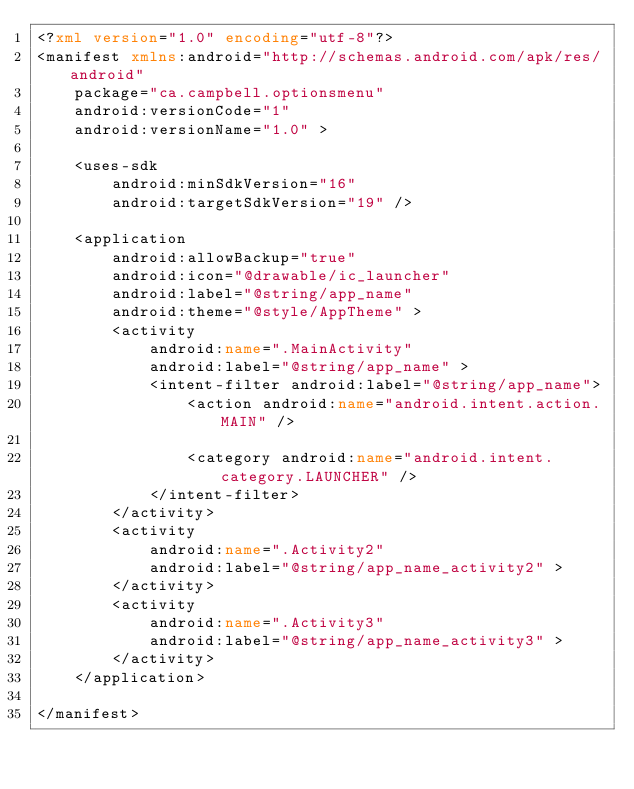<code> <loc_0><loc_0><loc_500><loc_500><_XML_><?xml version="1.0" encoding="utf-8"?>
<manifest xmlns:android="http://schemas.android.com/apk/res/android"
    package="ca.campbell.optionsmenu"
    android:versionCode="1"
    android:versionName="1.0" >

    <uses-sdk
        android:minSdkVersion="16"
        android:targetSdkVersion="19" />

    <application
        android:allowBackup="true"
        android:icon="@drawable/ic_launcher"
        android:label="@string/app_name"
        android:theme="@style/AppTheme" >
        <activity
            android:name=".MainActivity"
            android:label="@string/app_name" >
            <intent-filter android:label="@string/app_name">
                <action android:name="android.intent.action.MAIN" />

                <category android:name="android.intent.category.LAUNCHER" />
            </intent-filter>
        </activity>
        <activity
            android:name=".Activity2"
            android:label="@string/app_name_activity2" >
        </activity>
        <activity
            android:name=".Activity3"
            android:label="@string/app_name_activity3" >
        </activity>
    </application>

</manifest>
</code> 